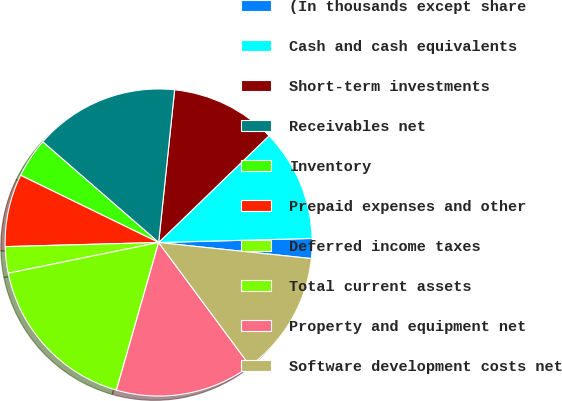Convert chart. <chart><loc_0><loc_0><loc_500><loc_500><pie_chart><fcel>(In thousands except share<fcel>Cash and cash equivalents<fcel>Short-term investments<fcel>Receivables net<fcel>Inventory<fcel>Prepaid expenses and other<fcel>Deferred income taxes<fcel>Total current assets<fcel>Property and equipment net<fcel>Software development costs net<nl><fcel>2.09%<fcel>11.81%<fcel>11.11%<fcel>15.28%<fcel>4.17%<fcel>7.64%<fcel>2.78%<fcel>17.36%<fcel>14.58%<fcel>13.19%<nl></chart> 